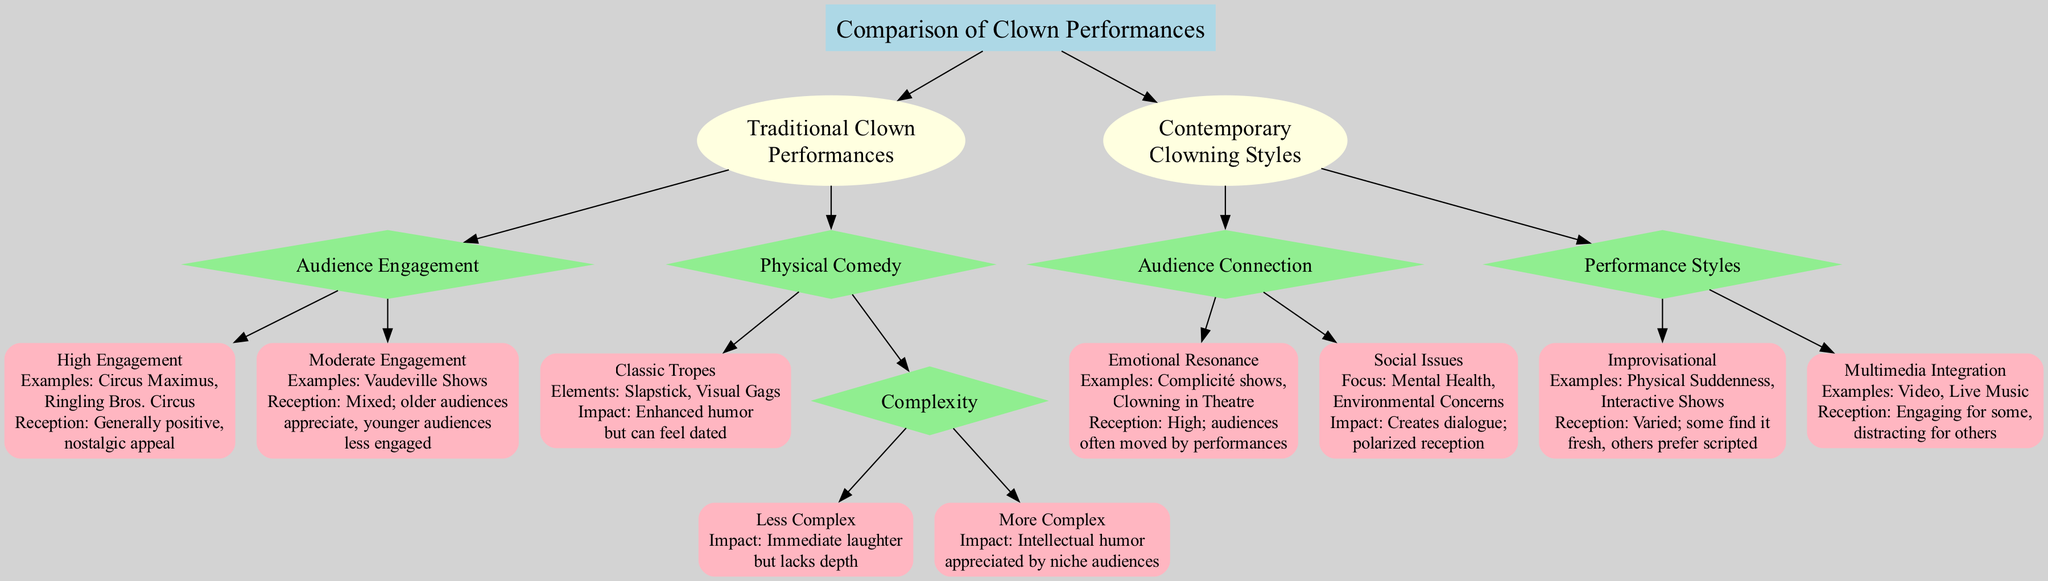What are the two main categories of clown performances? The diagram shows two main categories: Traditional Clown Performances and Contemporary Clowning Styles. This information is found directly under the root node.
Answer: Traditional Clown Performances, Contemporary Clowning Styles What is the impact of "Classic Tropes" in Traditional Clown Performances? Looking under the Traditional Clown Performances category, the node "Classic Tropes" specifies that its impact is "Enhanced humor but can feel dated." This is derived from the Physical Comedy section.
Answer: Enhanced humor but can feel dated How many examples are provided for "High Engagement" in Traditional Clown Performances? The "High Engagement" node lists two examples: "Circus Maximus" and "Ringling Bros. Circus." To arrive at this number, I count the examples listed within this node.
Answer: 2 What is the reception of the "Social Issues" category in Contemporary Clowning Styles? In the Contemporary Clowning Styles section, the "Social Issues" node states that the impact creates dialogue and has a polarized reception. Thus, I can directly reference this information.
Answer: Creates dialogue; polarized reception In which Traditional Clown Performance engagement level are younger audiences less engaged? Within the "Moderate Engagement" node, it explicitly indicates that older audiences appreciate it, while younger audiences are less engaged. This aligns with audience engagement analysis in this performance level.
Answer: Moderate Engagement What is the reception of "Emotional Resonance" in Contemporary Clowning Styles? Under the "Audience Connection" section, the "Emotional Resonance" node states that the reception is "High; audiences often moved by performances," directly answering the query about audience feelings.
Answer: High; audiences often moved by performances How many styles are listed under "Performance Styles" in Contemporary Clowning Styles? The "Performance Styles" section lists two styles: "Improvisational" and "Multimedia Integration." Counting these gives the number of styles directly related to performance methods.
Answer: 2 What type of humor is associated with "More Complex" in Physical Comedy? The "More Complex" node under Physical Comedy notes that its impact is "Intellectual humor appreciated by niche audiences." This allows me to identify the type of humor specified in the diagram.
Answer: Intellectual humor appreciated by niche audiences What examples are given under "Improvisational" in Contemporary Clowning Styles? The "Improvisational" node mentions two examples: "Physical Suddenness" and "Interactive Shows." Counting the examples within this node leads to the answer.
Answer: Physical Suddenness, Interactive Shows 